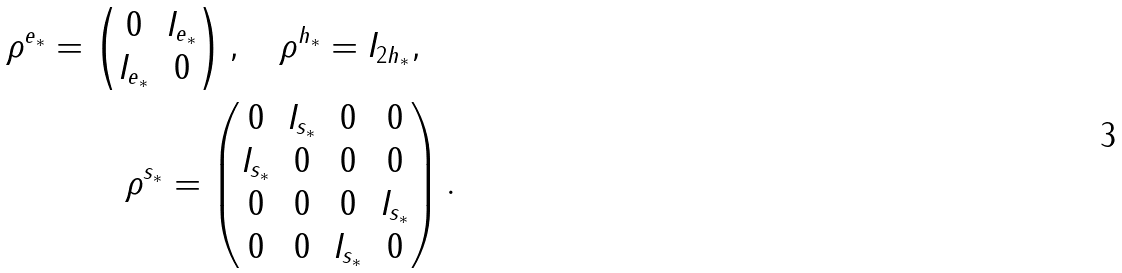Convert formula to latex. <formula><loc_0><loc_0><loc_500><loc_500>\rho ^ { e _ { * } } = \begin{pmatrix} 0 & I _ { e _ { * } } \\ I _ { e _ { * } } & 0 \end{pmatrix} , \quad \rho ^ { h _ { * } } = I _ { 2 h _ { * } } , \quad \\ \rho ^ { s _ { * } } = \begin{pmatrix} 0 & I _ { s _ { * } } & 0 & 0 \\ I _ { s _ { * } } & 0 & 0 & 0 \\ 0 & 0 & 0 & I _ { s _ { * } } \\ 0 & 0 & I _ { s _ { * } } & 0 \end{pmatrix} .</formula> 